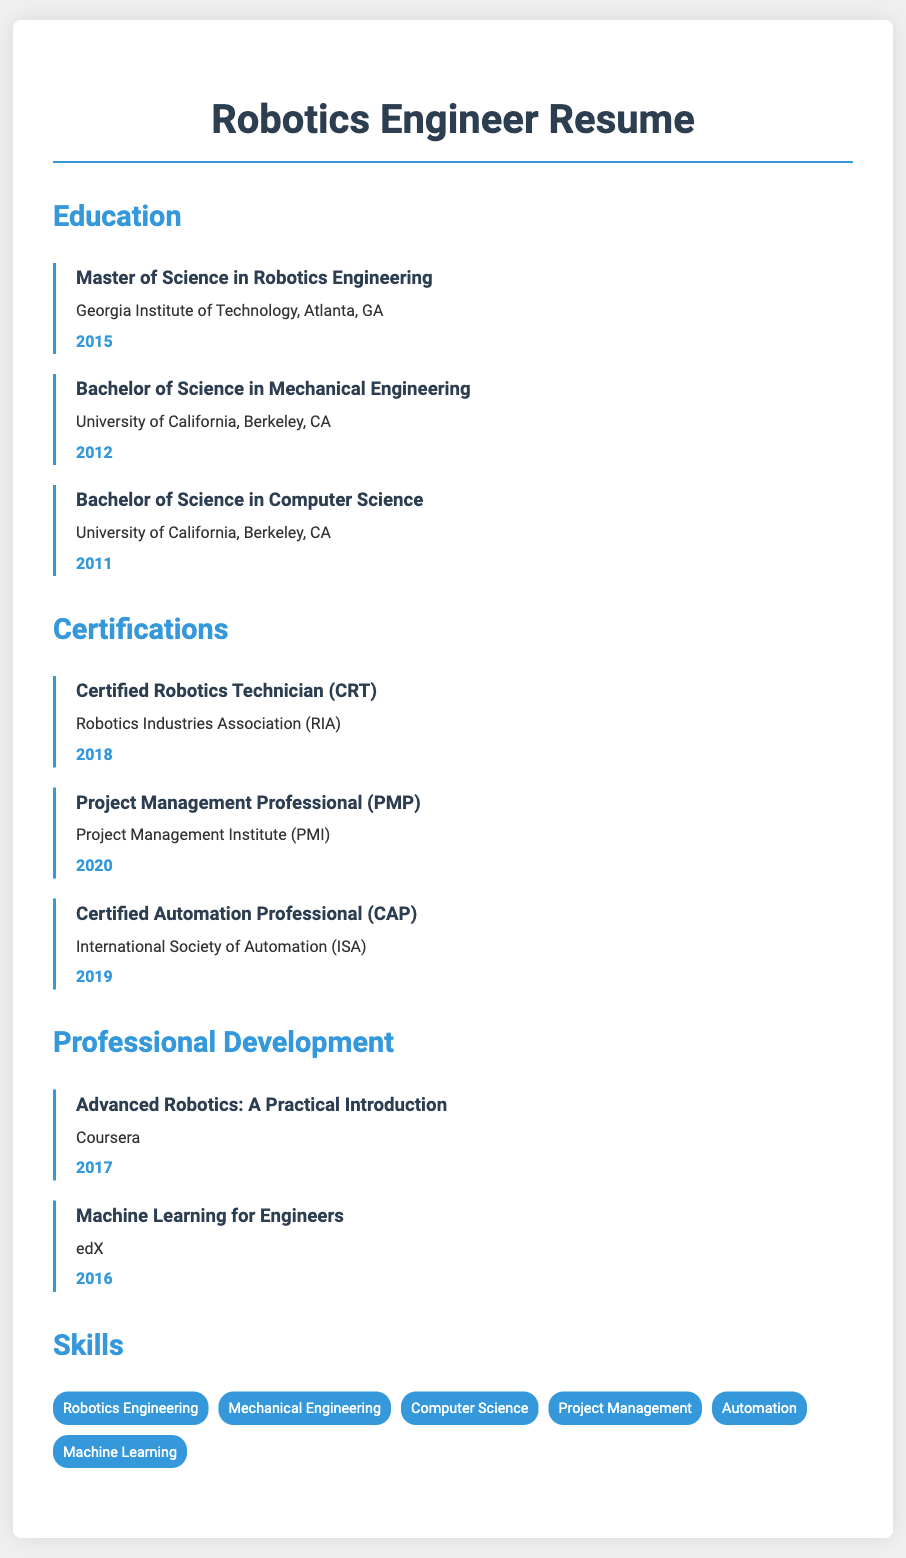what degree was obtained in 2015? The document states that the Master of Science in Robotics Engineering was obtained in 2015.
Answer: Master of Science in Robotics Engineering which university offered both a Bachelor of Science in Mechanical Engineering and Computer Science? The University of California, Berkeley, CA is mentioned as the institution providing both degrees.
Answer: University of California, Berkeley when was the Certified Robotics Technician obtained? The document indicates that the certification was attained in 2018.
Answer: 2018 how many Bachelor’s degrees are listed in the education section? There are three Bachelor’s degrees detailed in the education section of the resume.
Answer: three what certification was achieved after 2019? The Project Management Professional (PMP) certification was obtained in 2020, which is after 2019.
Answer: Project Management Professional (PMP) which educational institution is listed last in the education section? Both degrees from the University of California, Berkeley are listed before those from the Georgia Institute of Technology, making Georgia Institute of Technology the last listed.
Answer: Georgia Institute of Technology what is the latest certification mentioned? The document states that the most recent certification mentioned is the Project Management Professional (PMP) from 2020.
Answer: Project Management Professional (PMP) which section would you find the skills listed under? The skills are specified under the "Skills" section of the resume.
Answer: Skills 